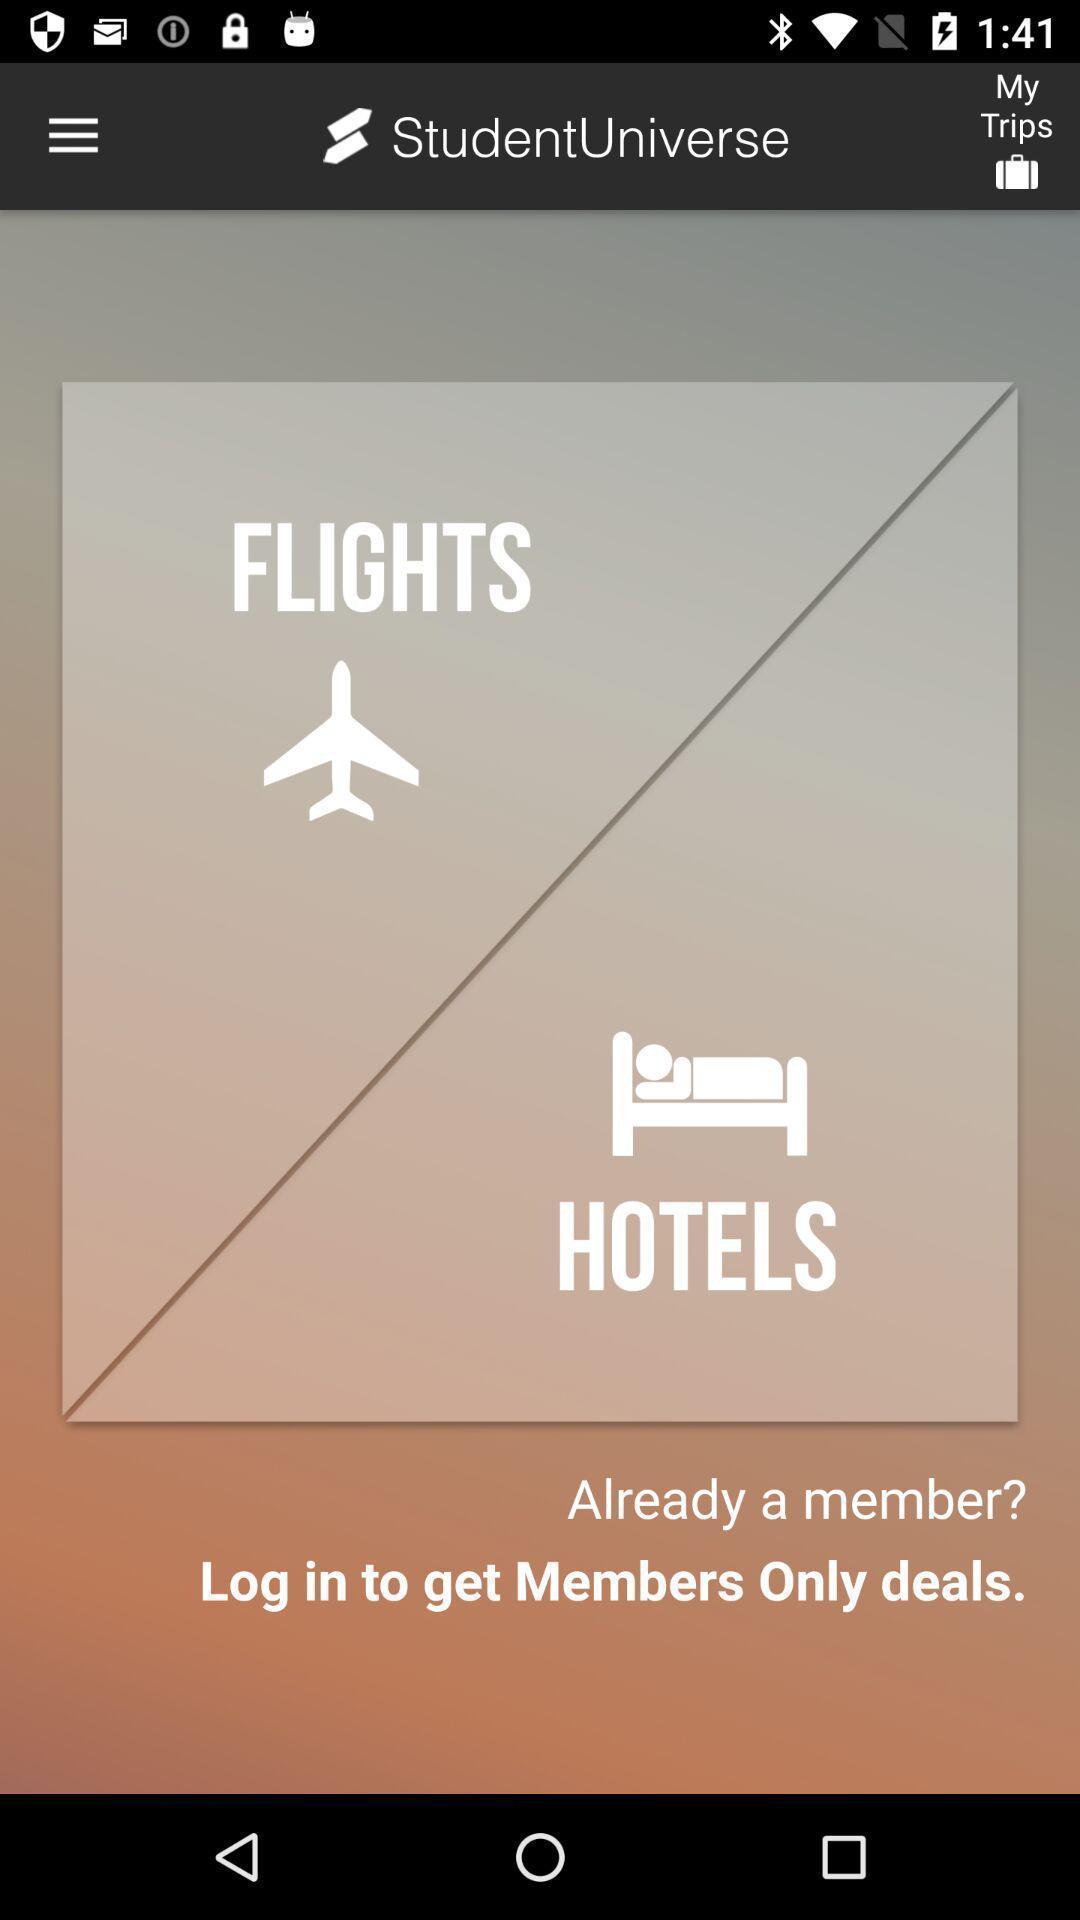Explain the elements present in this screenshot. Studentuniverse of flights and hotels app. 